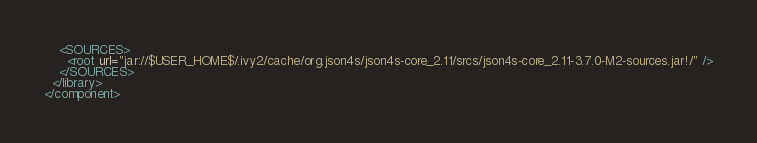Convert code to text. <code><loc_0><loc_0><loc_500><loc_500><_XML_>    <SOURCES>
      <root url="jar://$USER_HOME$/.ivy2/cache/org.json4s/json4s-core_2.11/srcs/json4s-core_2.11-3.7.0-M2-sources.jar!/" />
    </SOURCES>
  </library>
</component></code> 